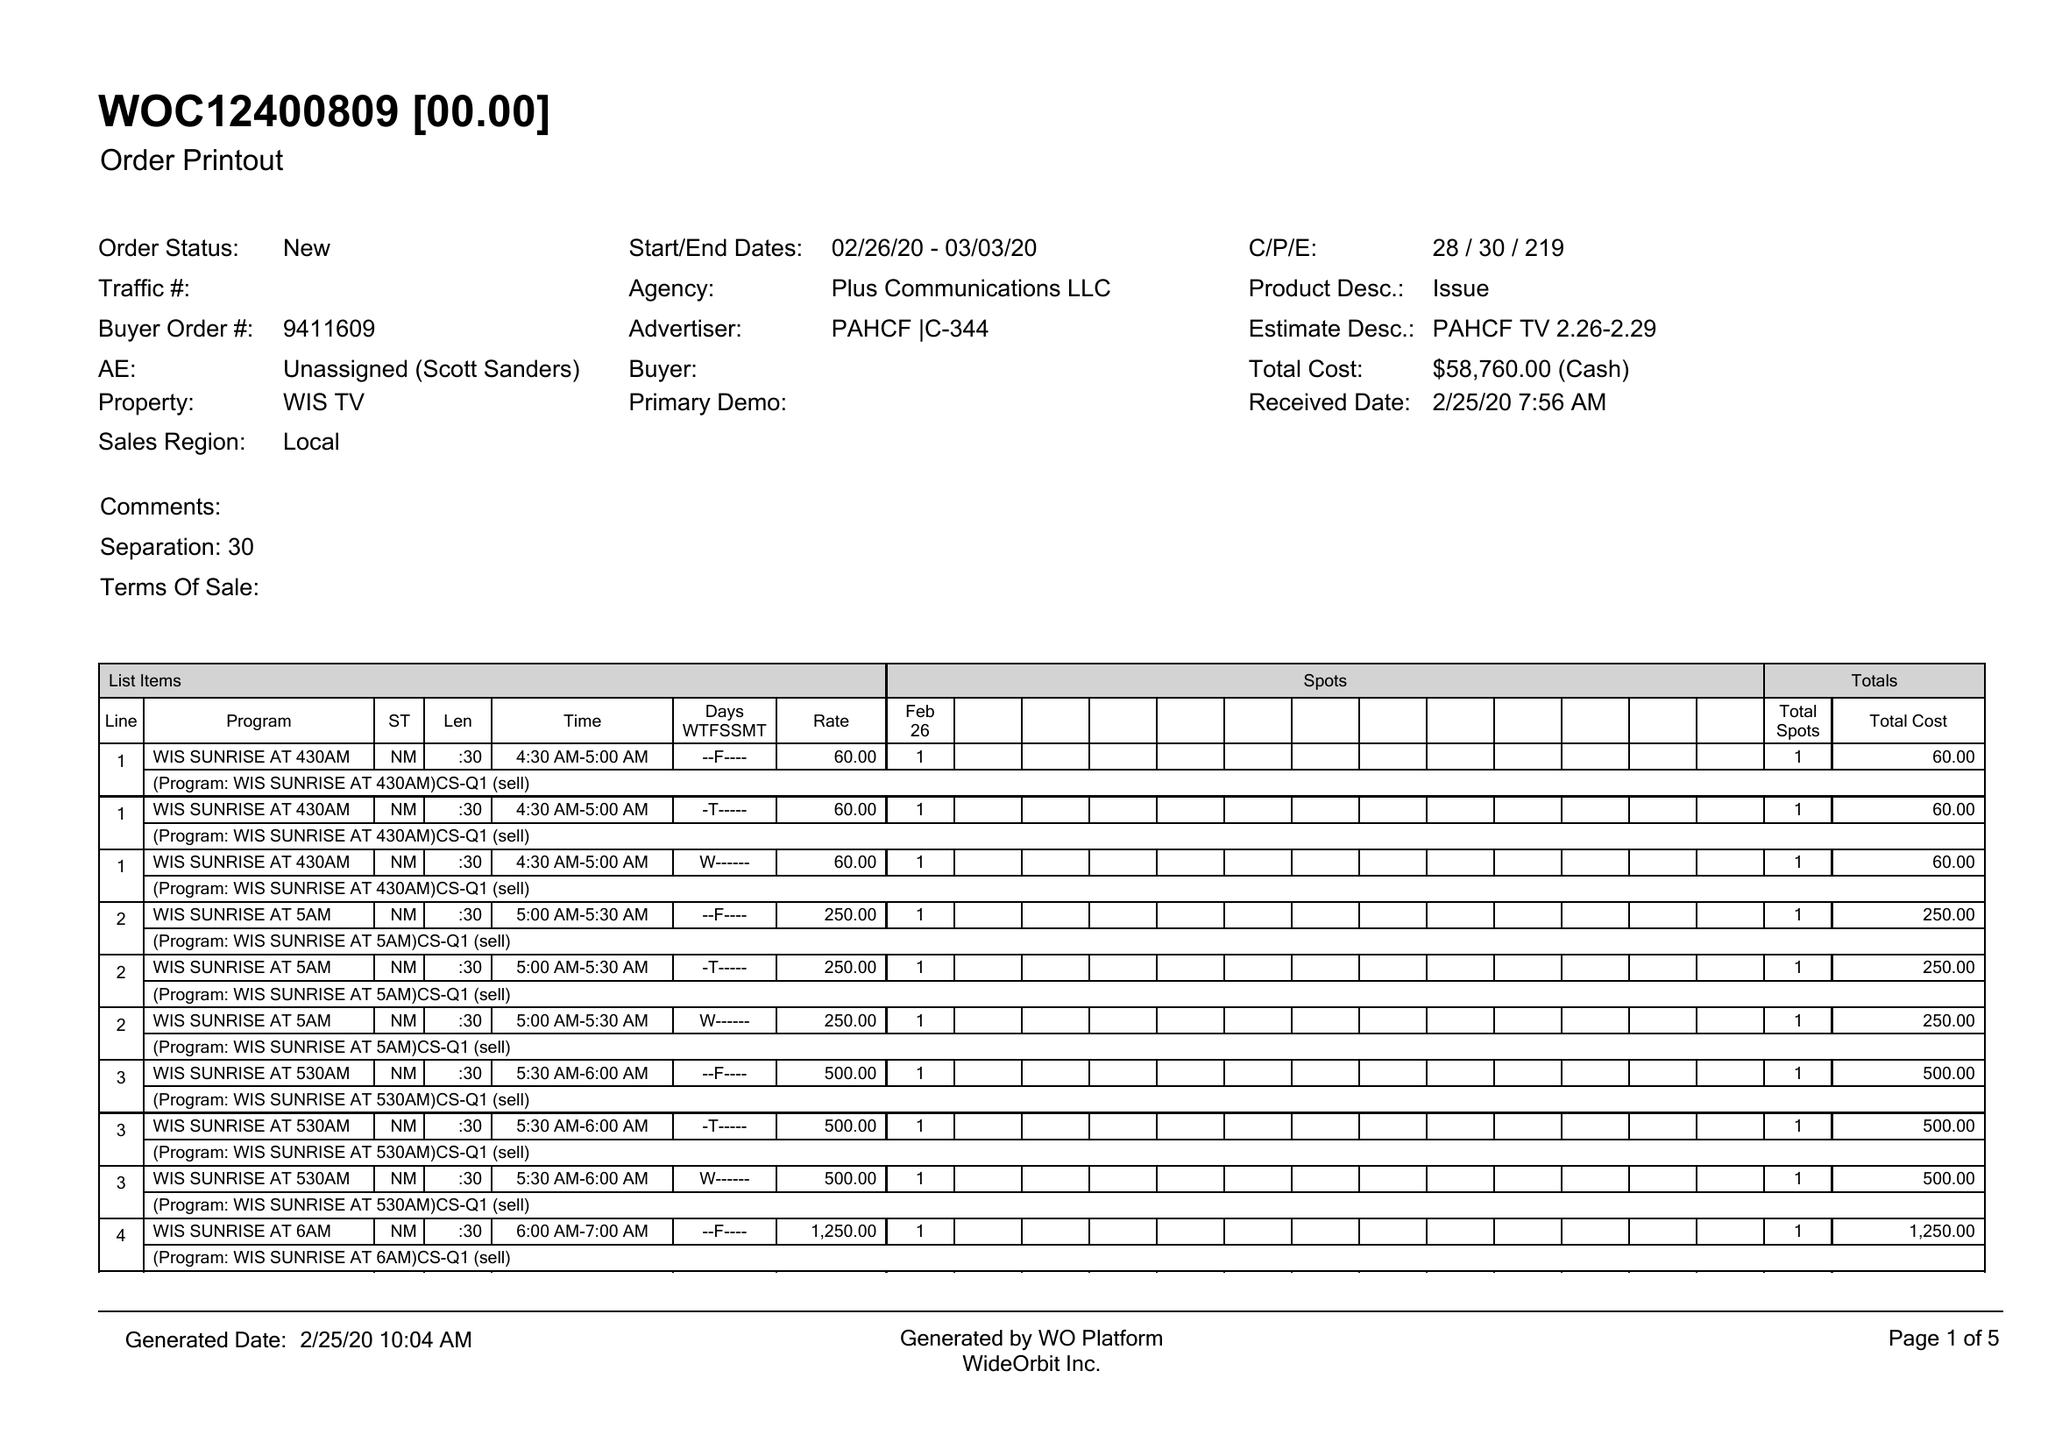What is the value for the advertiser?
Answer the question using a single word or phrase. PAHCF |C-344 